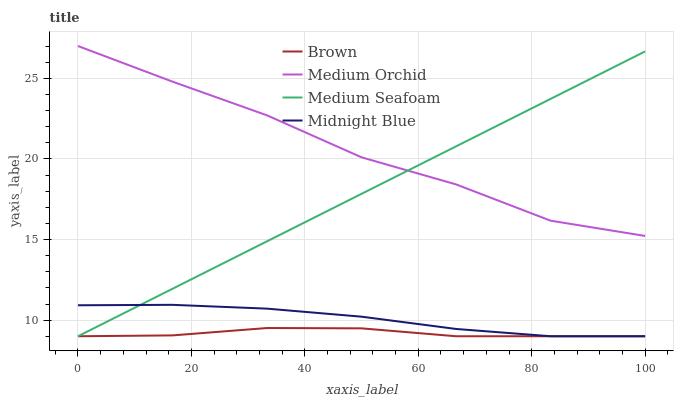Does Brown have the minimum area under the curve?
Answer yes or no. Yes. Does Medium Orchid have the maximum area under the curve?
Answer yes or no. Yes. Does Medium Seafoam have the minimum area under the curve?
Answer yes or no. No. Does Medium Seafoam have the maximum area under the curve?
Answer yes or no. No. Is Medium Seafoam the smoothest?
Answer yes or no. Yes. Is Medium Orchid the roughest?
Answer yes or no. Yes. Is Medium Orchid the smoothest?
Answer yes or no. No. Is Medium Seafoam the roughest?
Answer yes or no. No. Does Medium Orchid have the lowest value?
Answer yes or no. No. Does Medium Orchid have the highest value?
Answer yes or no. Yes. Does Medium Seafoam have the highest value?
Answer yes or no. No. Is Midnight Blue less than Medium Orchid?
Answer yes or no. Yes. Is Medium Orchid greater than Midnight Blue?
Answer yes or no. Yes. Does Medium Seafoam intersect Brown?
Answer yes or no. Yes. Is Medium Seafoam less than Brown?
Answer yes or no. No. Is Medium Seafoam greater than Brown?
Answer yes or no. No. Does Midnight Blue intersect Medium Orchid?
Answer yes or no. No. 